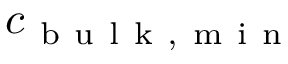Convert formula to latex. <formula><loc_0><loc_0><loc_500><loc_500>c _ { b u l k , m i n }</formula> 